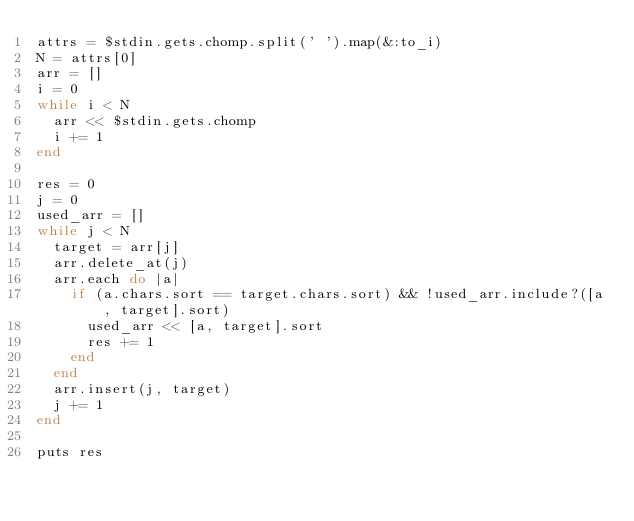Convert code to text. <code><loc_0><loc_0><loc_500><loc_500><_Ruby_>attrs = $stdin.gets.chomp.split(' ').map(&:to_i)
N = attrs[0]
arr = []
i = 0
while i < N
  arr << $stdin.gets.chomp
  i += 1
end

res = 0
j = 0
used_arr = []
while j < N
  target = arr[j]
  arr.delete_at(j)
  arr.each do |a|
    if (a.chars.sort == target.chars.sort) && !used_arr.include?([a, target].sort)
      used_arr << [a, target].sort
      res += 1
    end
  end
  arr.insert(j, target)
  j += 1
end

puts res
</code> 